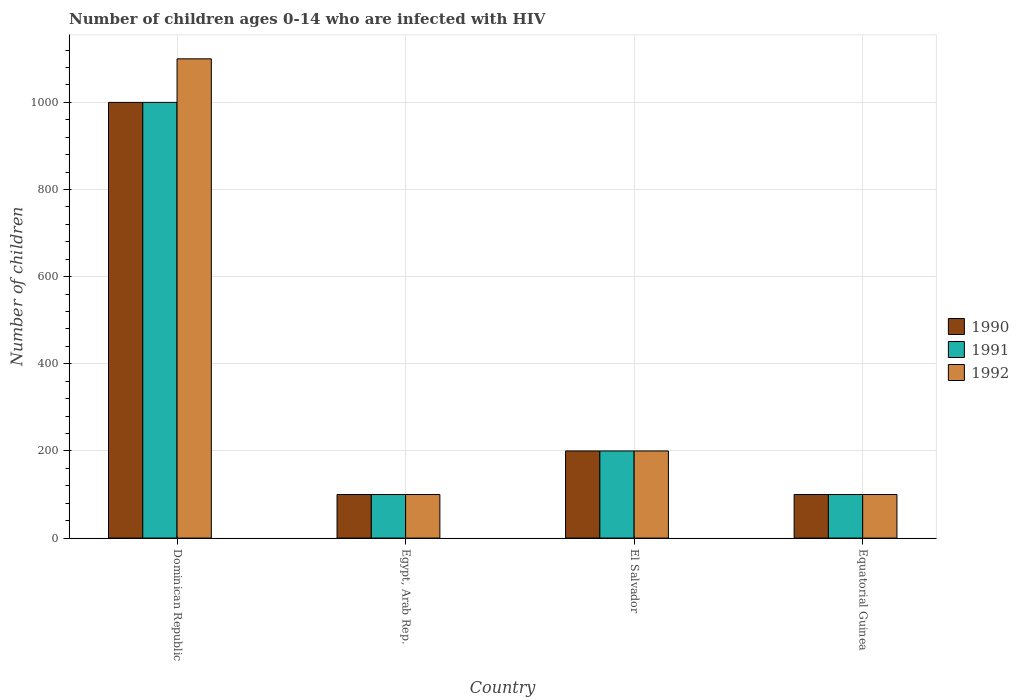Are the number of bars on each tick of the X-axis equal?
Offer a very short reply. Yes. How many bars are there on the 2nd tick from the left?
Ensure brevity in your answer.  3. How many bars are there on the 4th tick from the right?
Your answer should be very brief. 3. What is the label of the 1st group of bars from the left?
Keep it short and to the point. Dominican Republic. What is the number of HIV infected children in 1991 in Egypt, Arab Rep.?
Give a very brief answer. 100. Across all countries, what is the maximum number of HIV infected children in 1992?
Provide a succinct answer. 1100. Across all countries, what is the minimum number of HIV infected children in 1992?
Provide a short and direct response. 100. In which country was the number of HIV infected children in 1992 maximum?
Provide a short and direct response. Dominican Republic. In which country was the number of HIV infected children in 1991 minimum?
Offer a terse response. Egypt, Arab Rep. What is the total number of HIV infected children in 1990 in the graph?
Offer a terse response. 1400. What is the difference between the number of HIV infected children in 1990 in Egypt, Arab Rep. and that in El Salvador?
Provide a succinct answer. -100. What is the average number of HIV infected children in 1991 per country?
Keep it short and to the point. 350. What is the ratio of the number of HIV infected children in 1991 in Dominican Republic to that in El Salvador?
Make the answer very short. 5. What is the difference between the highest and the second highest number of HIV infected children in 1991?
Offer a very short reply. 900. What is the difference between the highest and the lowest number of HIV infected children in 1990?
Ensure brevity in your answer.  900. In how many countries, is the number of HIV infected children in 1992 greater than the average number of HIV infected children in 1992 taken over all countries?
Keep it short and to the point. 1. Is the sum of the number of HIV infected children in 1991 in El Salvador and Equatorial Guinea greater than the maximum number of HIV infected children in 1992 across all countries?
Your answer should be compact. No. What does the 1st bar from the right in Egypt, Arab Rep. represents?
Provide a short and direct response. 1992. Is it the case that in every country, the sum of the number of HIV infected children in 1992 and number of HIV infected children in 1990 is greater than the number of HIV infected children in 1991?
Offer a terse response. Yes. How many bars are there?
Offer a very short reply. 12. How many countries are there in the graph?
Offer a very short reply. 4. Are the values on the major ticks of Y-axis written in scientific E-notation?
Ensure brevity in your answer.  No. Does the graph contain any zero values?
Keep it short and to the point. No. Where does the legend appear in the graph?
Provide a succinct answer. Center right. What is the title of the graph?
Ensure brevity in your answer.  Number of children ages 0-14 who are infected with HIV. What is the label or title of the X-axis?
Offer a terse response. Country. What is the label or title of the Y-axis?
Give a very brief answer. Number of children. What is the Number of children of 1990 in Dominican Republic?
Your answer should be compact. 1000. What is the Number of children in 1992 in Dominican Republic?
Your response must be concise. 1100. What is the Number of children of 1991 in Egypt, Arab Rep.?
Keep it short and to the point. 100. What is the Number of children in 1991 in El Salvador?
Your answer should be very brief. 200. What is the Number of children in 1990 in Equatorial Guinea?
Give a very brief answer. 100. Across all countries, what is the maximum Number of children of 1990?
Ensure brevity in your answer.  1000. Across all countries, what is the maximum Number of children of 1992?
Ensure brevity in your answer.  1100. Across all countries, what is the minimum Number of children of 1990?
Keep it short and to the point. 100. What is the total Number of children of 1990 in the graph?
Your answer should be compact. 1400. What is the total Number of children in 1991 in the graph?
Make the answer very short. 1400. What is the total Number of children of 1992 in the graph?
Make the answer very short. 1500. What is the difference between the Number of children of 1990 in Dominican Republic and that in Egypt, Arab Rep.?
Provide a short and direct response. 900. What is the difference between the Number of children of 1991 in Dominican Republic and that in Egypt, Arab Rep.?
Offer a terse response. 900. What is the difference between the Number of children of 1990 in Dominican Republic and that in El Salvador?
Your response must be concise. 800. What is the difference between the Number of children of 1991 in Dominican Republic and that in El Salvador?
Provide a succinct answer. 800. What is the difference between the Number of children in 1992 in Dominican Republic and that in El Salvador?
Make the answer very short. 900. What is the difference between the Number of children of 1990 in Dominican Republic and that in Equatorial Guinea?
Ensure brevity in your answer.  900. What is the difference between the Number of children in 1991 in Dominican Republic and that in Equatorial Guinea?
Give a very brief answer. 900. What is the difference between the Number of children in 1992 in Dominican Republic and that in Equatorial Guinea?
Provide a succinct answer. 1000. What is the difference between the Number of children in 1990 in Egypt, Arab Rep. and that in El Salvador?
Your answer should be very brief. -100. What is the difference between the Number of children in 1991 in Egypt, Arab Rep. and that in El Salvador?
Provide a succinct answer. -100. What is the difference between the Number of children of 1992 in Egypt, Arab Rep. and that in El Salvador?
Ensure brevity in your answer.  -100. What is the difference between the Number of children in 1991 in Egypt, Arab Rep. and that in Equatorial Guinea?
Provide a short and direct response. 0. What is the difference between the Number of children in 1992 in Egypt, Arab Rep. and that in Equatorial Guinea?
Offer a terse response. 0. What is the difference between the Number of children of 1991 in El Salvador and that in Equatorial Guinea?
Give a very brief answer. 100. What is the difference between the Number of children of 1990 in Dominican Republic and the Number of children of 1991 in Egypt, Arab Rep.?
Make the answer very short. 900. What is the difference between the Number of children in 1990 in Dominican Republic and the Number of children in 1992 in Egypt, Arab Rep.?
Ensure brevity in your answer.  900. What is the difference between the Number of children in 1991 in Dominican Republic and the Number of children in 1992 in Egypt, Arab Rep.?
Provide a succinct answer. 900. What is the difference between the Number of children in 1990 in Dominican Republic and the Number of children in 1991 in El Salvador?
Provide a succinct answer. 800. What is the difference between the Number of children of 1990 in Dominican Republic and the Number of children of 1992 in El Salvador?
Your answer should be very brief. 800. What is the difference between the Number of children in 1991 in Dominican Republic and the Number of children in 1992 in El Salvador?
Your answer should be very brief. 800. What is the difference between the Number of children of 1990 in Dominican Republic and the Number of children of 1991 in Equatorial Guinea?
Provide a succinct answer. 900. What is the difference between the Number of children of 1990 in Dominican Republic and the Number of children of 1992 in Equatorial Guinea?
Ensure brevity in your answer.  900. What is the difference between the Number of children in 1991 in Dominican Republic and the Number of children in 1992 in Equatorial Guinea?
Provide a short and direct response. 900. What is the difference between the Number of children of 1990 in Egypt, Arab Rep. and the Number of children of 1991 in El Salvador?
Give a very brief answer. -100. What is the difference between the Number of children of 1990 in Egypt, Arab Rep. and the Number of children of 1992 in El Salvador?
Offer a terse response. -100. What is the difference between the Number of children of 1991 in Egypt, Arab Rep. and the Number of children of 1992 in El Salvador?
Keep it short and to the point. -100. What is the difference between the Number of children of 1990 in Egypt, Arab Rep. and the Number of children of 1992 in Equatorial Guinea?
Your answer should be compact. 0. What is the difference between the Number of children in 1991 in Egypt, Arab Rep. and the Number of children in 1992 in Equatorial Guinea?
Make the answer very short. 0. What is the difference between the Number of children of 1991 in El Salvador and the Number of children of 1992 in Equatorial Guinea?
Offer a terse response. 100. What is the average Number of children of 1990 per country?
Offer a very short reply. 350. What is the average Number of children in 1991 per country?
Make the answer very short. 350. What is the average Number of children in 1992 per country?
Keep it short and to the point. 375. What is the difference between the Number of children in 1990 and Number of children in 1991 in Dominican Republic?
Offer a terse response. 0. What is the difference between the Number of children of 1990 and Number of children of 1992 in Dominican Republic?
Your answer should be very brief. -100. What is the difference between the Number of children of 1991 and Number of children of 1992 in Dominican Republic?
Your answer should be compact. -100. What is the difference between the Number of children in 1990 and Number of children in 1991 in El Salvador?
Provide a short and direct response. 0. What is the difference between the Number of children in 1991 and Number of children in 1992 in El Salvador?
Provide a short and direct response. 0. What is the difference between the Number of children in 1990 and Number of children in 1992 in Equatorial Guinea?
Your answer should be compact. 0. What is the ratio of the Number of children of 1992 in Dominican Republic to that in Egypt, Arab Rep.?
Make the answer very short. 11. What is the ratio of the Number of children in 1990 in Dominican Republic to that in El Salvador?
Provide a short and direct response. 5. What is the ratio of the Number of children of 1992 in Dominican Republic to that in El Salvador?
Provide a succinct answer. 5.5. What is the ratio of the Number of children in 1991 in Dominican Republic to that in Equatorial Guinea?
Give a very brief answer. 10. What is the ratio of the Number of children in 1991 in Egypt, Arab Rep. to that in El Salvador?
Give a very brief answer. 0.5. What is the ratio of the Number of children of 1990 in Egypt, Arab Rep. to that in Equatorial Guinea?
Your answer should be very brief. 1. What is the ratio of the Number of children in 1992 in Egypt, Arab Rep. to that in Equatorial Guinea?
Your answer should be compact. 1. What is the ratio of the Number of children of 1990 in El Salvador to that in Equatorial Guinea?
Your answer should be very brief. 2. What is the difference between the highest and the second highest Number of children of 1990?
Provide a short and direct response. 800. What is the difference between the highest and the second highest Number of children in 1991?
Offer a very short reply. 800. What is the difference between the highest and the second highest Number of children in 1992?
Offer a terse response. 900. What is the difference between the highest and the lowest Number of children in 1990?
Make the answer very short. 900. What is the difference between the highest and the lowest Number of children in 1991?
Make the answer very short. 900. What is the difference between the highest and the lowest Number of children of 1992?
Make the answer very short. 1000. 